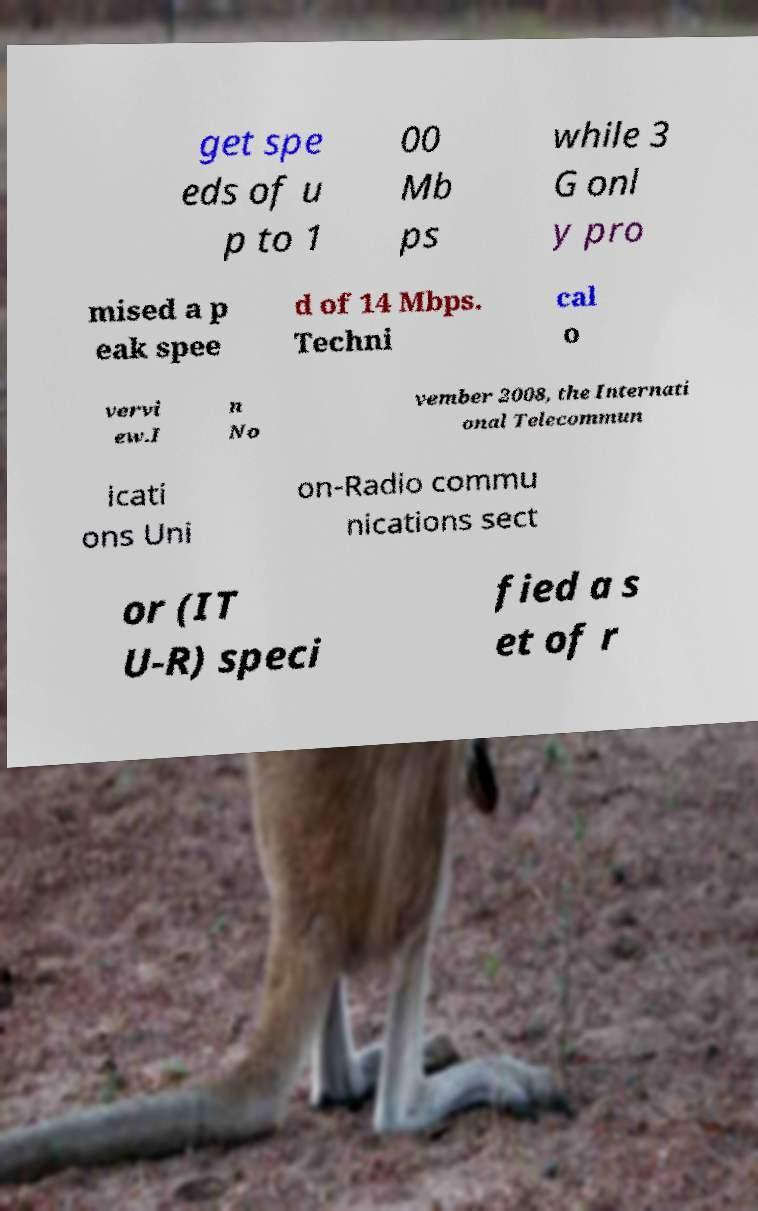Please identify and transcribe the text found in this image. get spe eds of u p to 1 00 Mb ps while 3 G onl y pro mised a p eak spee d of 14 Mbps. Techni cal o vervi ew.I n No vember 2008, the Internati onal Telecommun icati ons Uni on-Radio commu nications sect or (IT U-R) speci fied a s et of r 